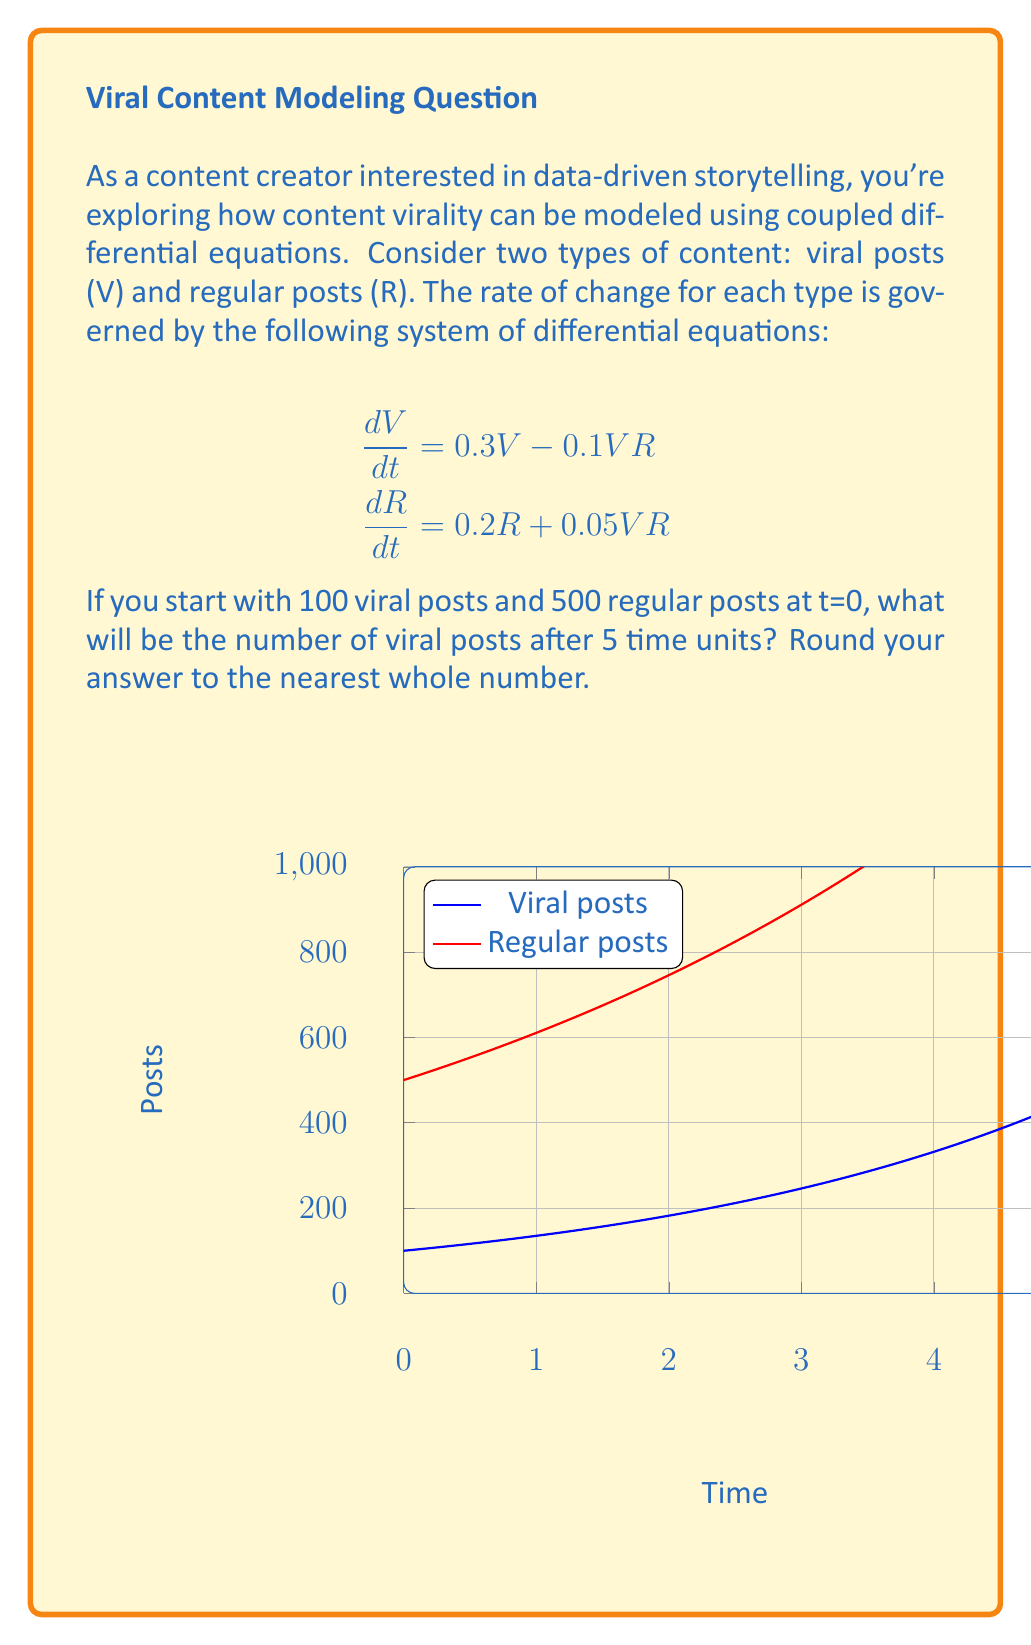What is the answer to this math problem? To solve this problem, we need to follow these steps:

1) First, note that the system of equations is nonlinear due to the VR terms, making it difficult to solve analytically. However, we can make an approximation by assuming that the interaction terms (VR) are small compared to the linear terms in the short term.

2) With this approximation, we can treat the equations as uncoupled:

   $$\frac{dV}{dt} \approx 0.3V$$
   $$\frac{dR}{dt} \approx 0.2R$$

3) These simplified equations have the general solutions:

   $$V(t) \approx V_0e^{0.3t}$$
   $$R(t) \approx R_0e^{0.2t}$$

   where $V_0$ and $R_0$ are the initial numbers of viral and regular posts, respectively.

4) We're given that $V_0 = 100$ and $R_0 = 500$, and we need to find $V(5)$:

   $$V(5) \approx 100e^{0.3 * 5}$$

5) Calculate this value:

   $$V(5) \approx 100e^{1.5} \approx 100 * 4.4817 \approx 448.17$$

6) Rounding to the nearest whole number, we get 448.

Note: This is an approximation. In reality, the interaction between viral and regular posts would affect the growth, potentially leading to a different result. For more accurate results, numerical methods would be needed to solve the full nonlinear system.
Answer: 448 viral posts 